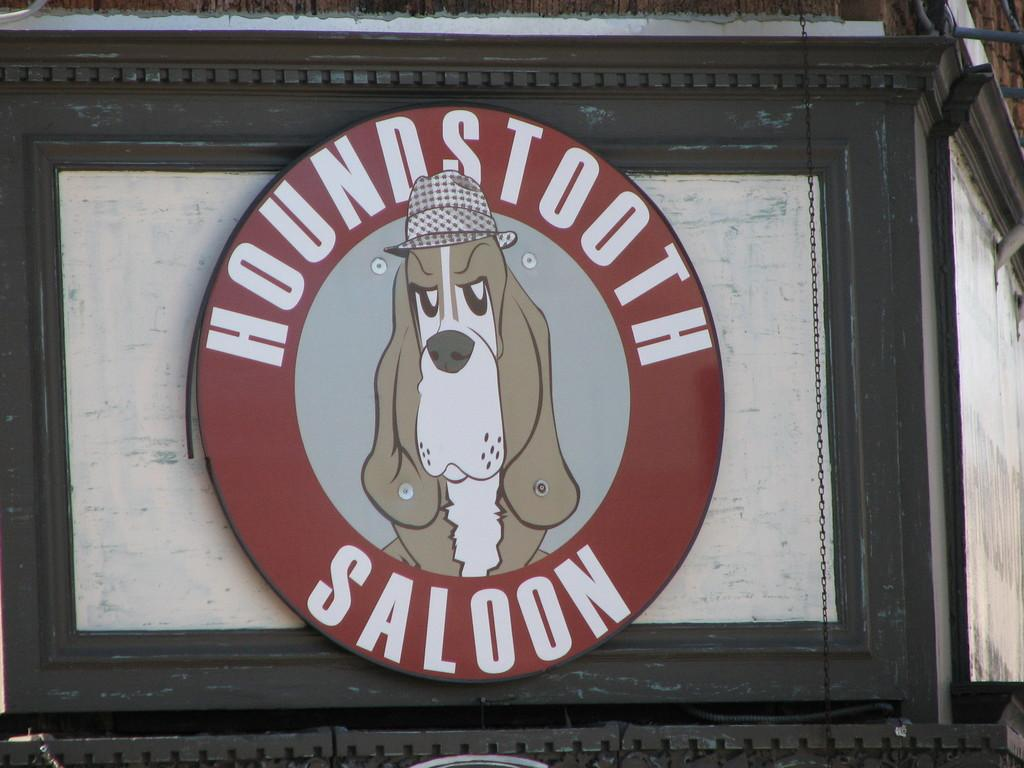What object is present in the image that typically holds a photograph? There is a photo frame in the image. What type of image is displayed in the photo frame? The photo frame contains an animal picture. Is there any text present within the photo frame? Yes, there is text in the photo frame. What type of sheet is used to cover the animal in the image? There is no sheet present in the image, and the animal is a picture within the photo frame. 